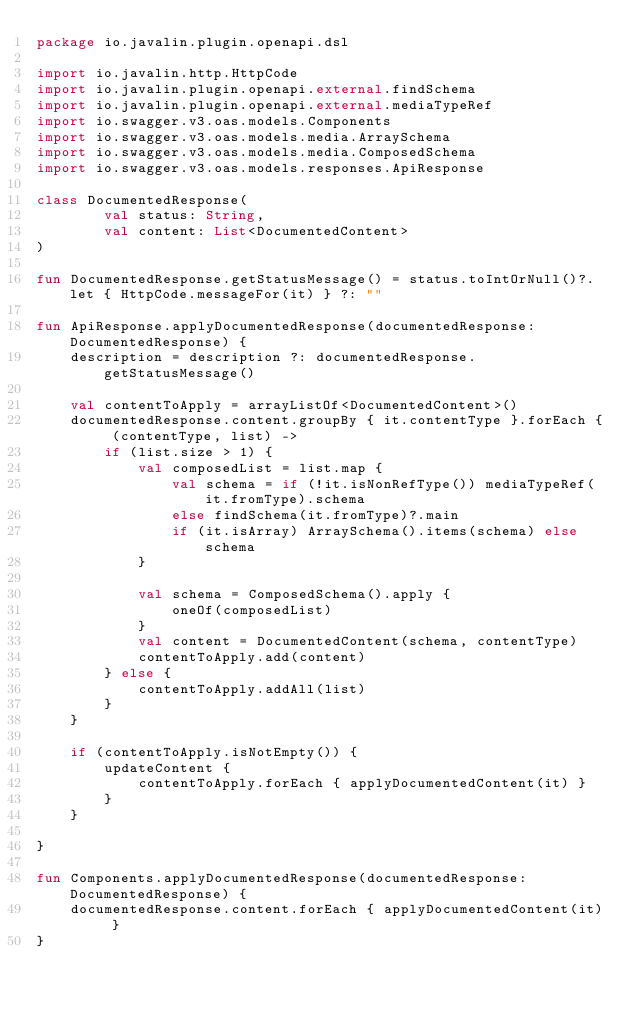<code> <loc_0><loc_0><loc_500><loc_500><_Kotlin_>package io.javalin.plugin.openapi.dsl

import io.javalin.http.HttpCode
import io.javalin.plugin.openapi.external.findSchema
import io.javalin.plugin.openapi.external.mediaTypeRef
import io.swagger.v3.oas.models.Components
import io.swagger.v3.oas.models.media.ArraySchema
import io.swagger.v3.oas.models.media.ComposedSchema
import io.swagger.v3.oas.models.responses.ApiResponse

class DocumentedResponse(
        val status: String,
        val content: List<DocumentedContent>
)

fun DocumentedResponse.getStatusMessage() = status.toIntOrNull()?.let { HttpCode.messageFor(it) } ?: ""

fun ApiResponse.applyDocumentedResponse(documentedResponse: DocumentedResponse) {
    description = description ?: documentedResponse.getStatusMessage()

    val contentToApply = arrayListOf<DocumentedContent>()
    documentedResponse.content.groupBy { it.contentType }.forEach { (contentType, list) ->
        if (list.size > 1) {
            val composedList = list.map {
                val schema = if (!it.isNonRefType()) mediaTypeRef(it.fromType).schema
                else findSchema(it.fromType)?.main
                if (it.isArray) ArraySchema().items(schema) else schema
            }

            val schema = ComposedSchema().apply {
                oneOf(composedList)
            }
            val content = DocumentedContent(schema, contentType)
            contentToApply.add(content)
        } else {
            contentToApply.addAll(list)
        }
    }

    if (contentToApply.isNotEmpty()) {
        updateContent {
            contentToApply.forEach { applyDocumentedContent(it) }
        }
    }

}

fun Components.applyDocumentedResponse(documentedResponse: DocumentedResponse) {
    documentedResponse.content.forEach { applyDocumentedContent(it) }
}
</code> 